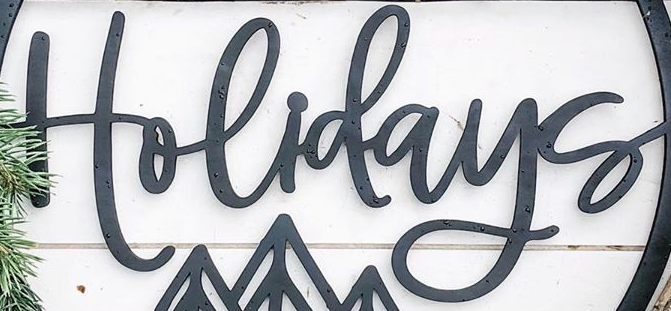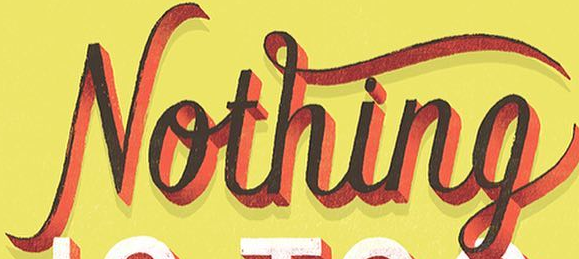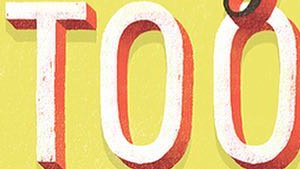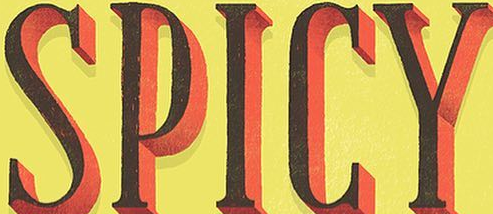What text appears in these images from left to right, separated by a semicolon? Holidays; Nothing; TOO; SPICY 